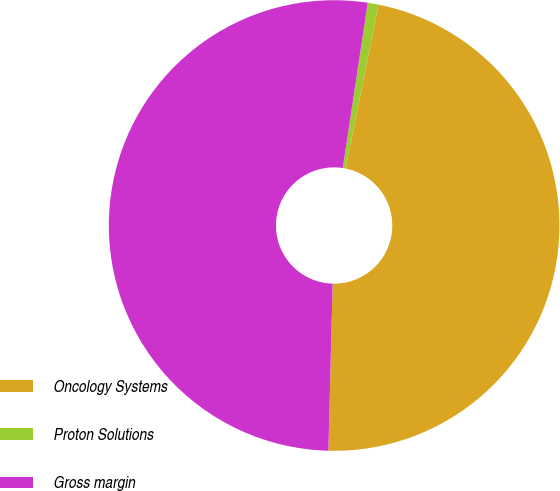<chart> <loc_0><loc_0><loc_500><loc_500><pie_chart><fcel>Oncology Systems<fcel>Proton Solutions<fcel>Gross margin<nl><fcel>47.25%<fcel>0.77%<fcel>51.98%<nl></chart> 